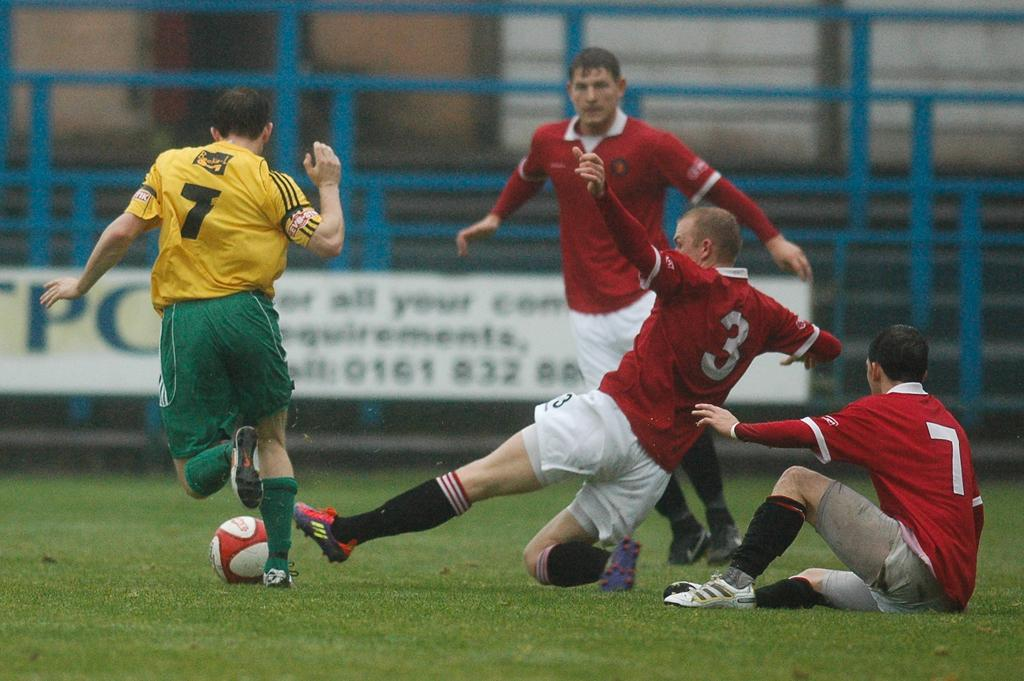<image>
Present a compact description of the photo's key features. The players numbered three and seven try to take the ball from the opposing number seven. 